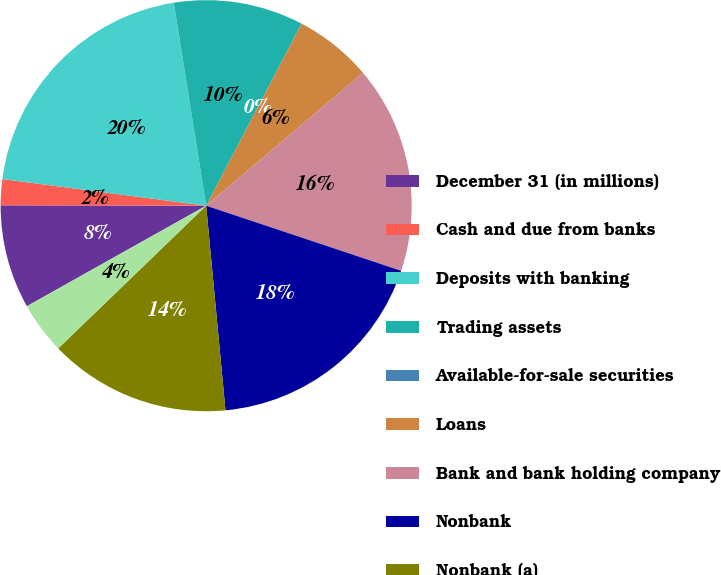Convert chart. <chart><loc_0><loc_0><loc_500><loc_500><pie_chart><fcel>December 31 (in millions)<fcel>Cash and due from banks<fcel>Deposits with banking<fcel>Trading assets<fcel>Available-for-sale securities<fcel>Loans<fcel>Bank and bank holding company<fcel>Nonbank<fcel>Nonbank (a)<fcel>Goodwill and other intangibles<nl><fcel>8.16%<fcel>2.04%<fcel>20.41%<fcel>10.2%<fcel>0.0%<fcel>6.12%<fcel>16.32%<fcel>18.37%<fcel>14.28%<fcel>4.08%<nl></chart> 